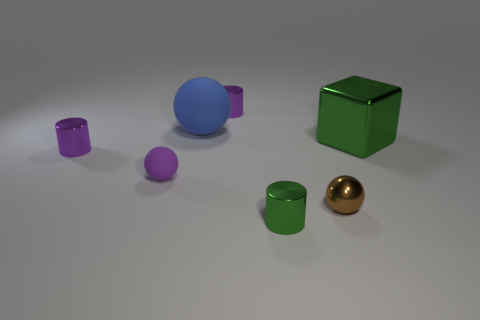What number of other things are there of the same color as the small matte thing?
Your response must be concise. 2. Is the color of the large matte ball the same as the small metal ball?
Your answer should be very brief. No. How many small green metallic things are there?
Provide a succinct answer. 1. There is a green object right of the green shiny object in front of the metal sphere; what is it made of?
Provide a short and direct response. Metal. There is another sphere that is the same size as the metal sphere; what is its material?
Keep it short and to the point. Rubber. There is a green metal thing to the right of the brown shiny ball; is it the same size as the blue rubber thing?
Keep it short and to the point. Yes. Is the shape of the purple metallic thing in front of the cube the same as  the small green metal object?
Offer a very short reply. Yes. What number of things are either purple matte objects or objects behind the small metallic sphere?
Give a very brief answer. 5. Are there fewer small brown rubber cylinders than green blocks?
Provide a succinct answer. Yes. Are there more purple metal balls than tiny cylinders?
Provide a succinct answer. No. 